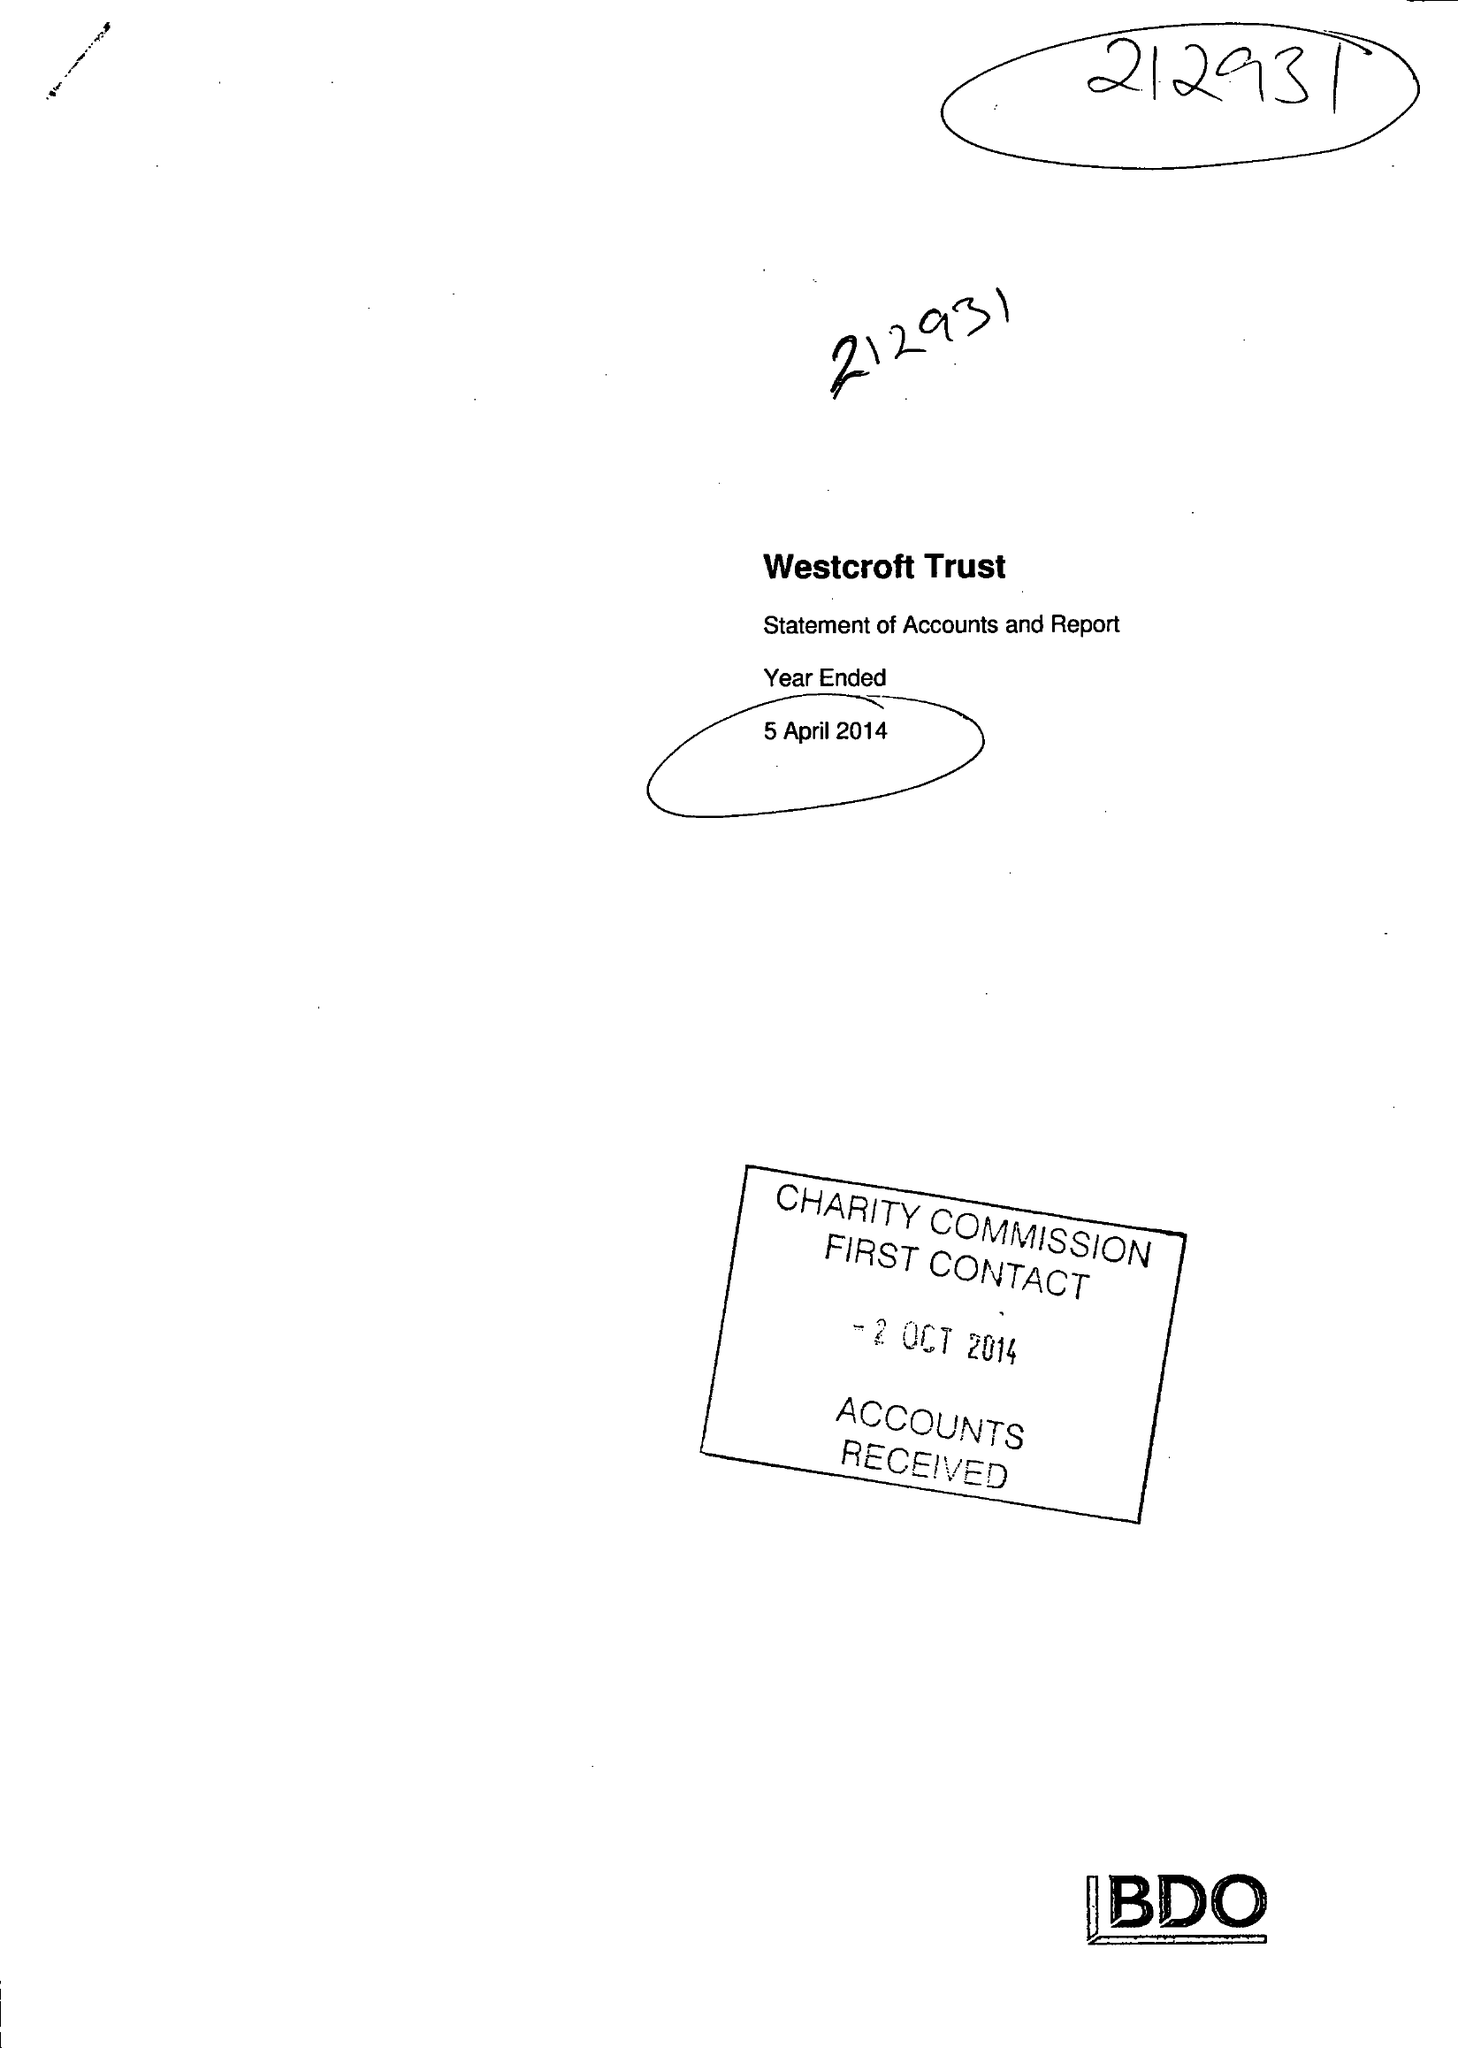What is the value for the report_date?
Answer the question using a single word or phrase. 2014-04-05 